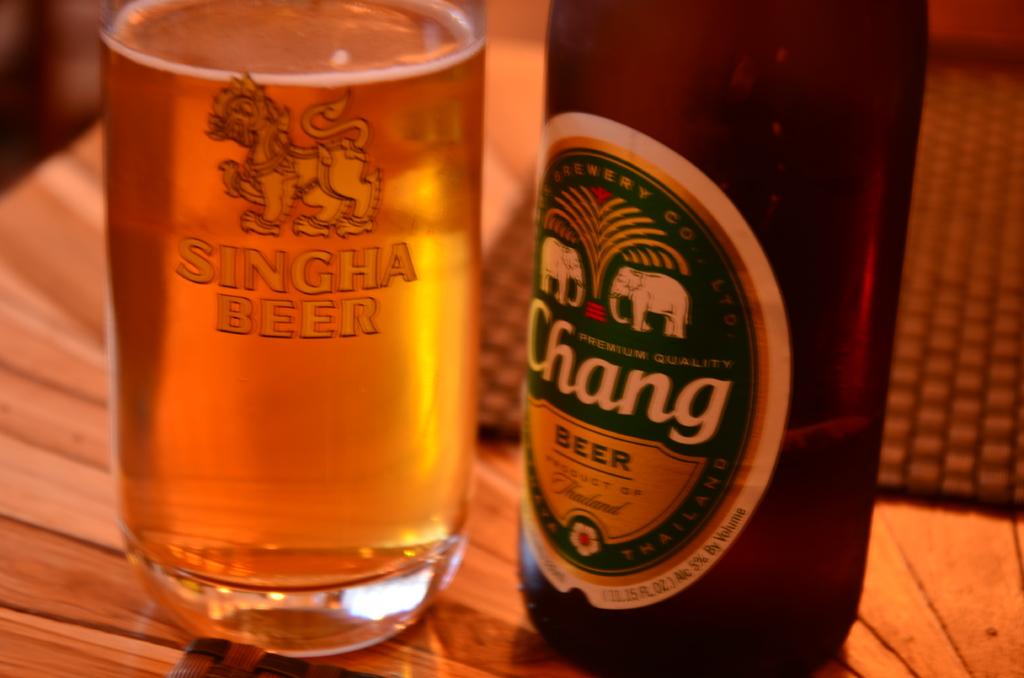What brand of beer is listed on the glass to the left?
Offer a very short reply. Singha. What does the beer bottle say?
Offer a terse response. Chang beer. 